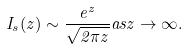Convert formula to latex. <formula><loc_0><loc_0><loc_500><loc_500>I _ { s } ( z ) \sim \frac { e ^ { z } } { \sqrt { 2 \pi z } } a s z \rightarrow \infty .</formula> 